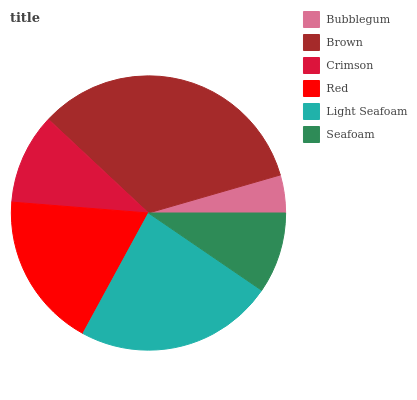Is Bubblegum the minimum?
Answer yes or no. Yes. Is Brown the maximum?
Answer yes or no. Yes. Is Crimson the minimum?
Answer yes or no. No. Is Crimson the maximum?
Answer yes or no. No. Is Brown greater than Crimson?
Answer yes or no. Yes. Is Crimson less than Brown?
Answer yes or no. Yes. Is Crimson greater than Brown?
Answer yes or no. No. Is Brown less than Crimson?
Answer yes or no. No. Is Red the high median?
Answer yes or no. Yes. Is Crimson the low median?
Answer yes or no. Yes. Is Light Seafoam the high median?
Answer yes or no. No. Is Seafoam the low median?
Answer yes or no. No. 